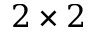<formula> <loc_0><loc_0><loc_500><loc_500>2 \times 2</formula> 